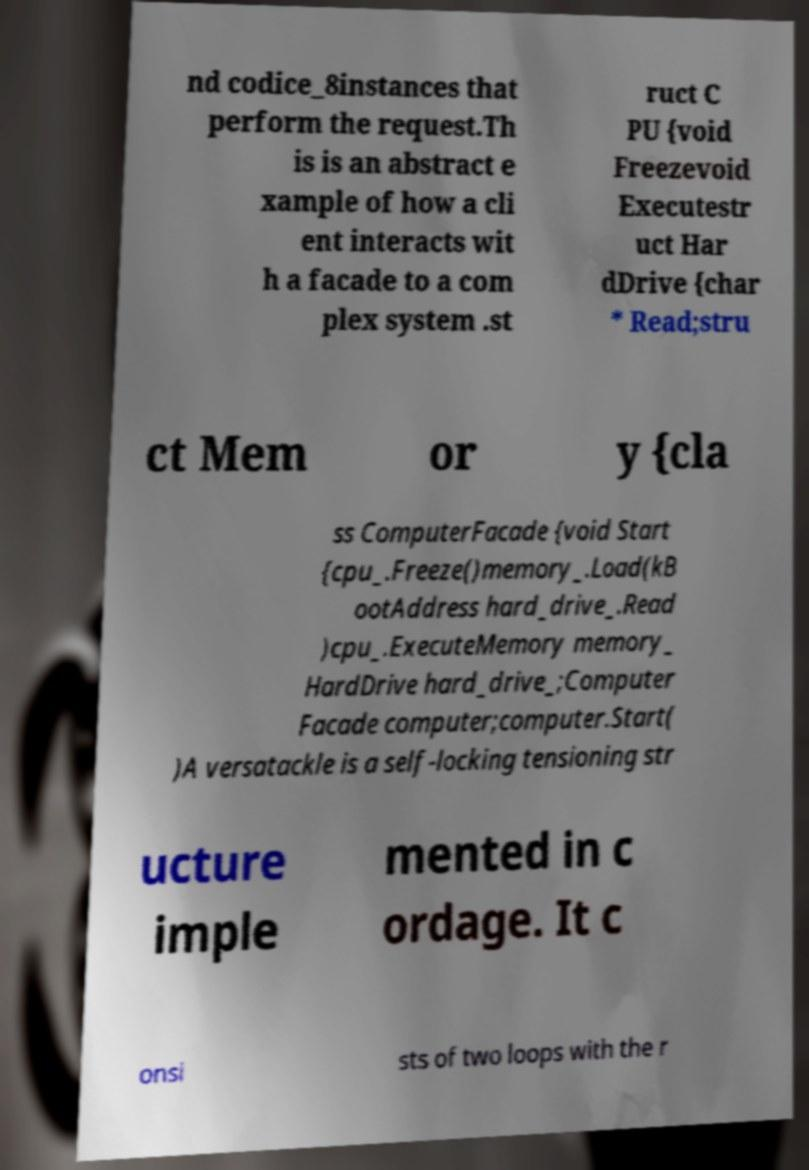What messages or text are displayed in this image? I need them in a readable, typed format. nd codice_8instances that perform the request.Th is is an abstract e xample of how a cli ent interacts wit h a facade to a com plex system .st ruct C PU {void Freezevoid Executestr uct Har dDrive {char * Read;stru ct Mem or y {cla ss ComputerFacade {void Start {cpu_.Freeze()memory_.Load(kB ootAddress hard_drive_.Read )cpu_.ExecuteMemory memory_ HardDrive hard_drive_;Computer Facade computer;computer.Start( )A versatackle is a self-locking tensioning str ucture imple mented in c ordage. It c onsi sts of two loops with the r 